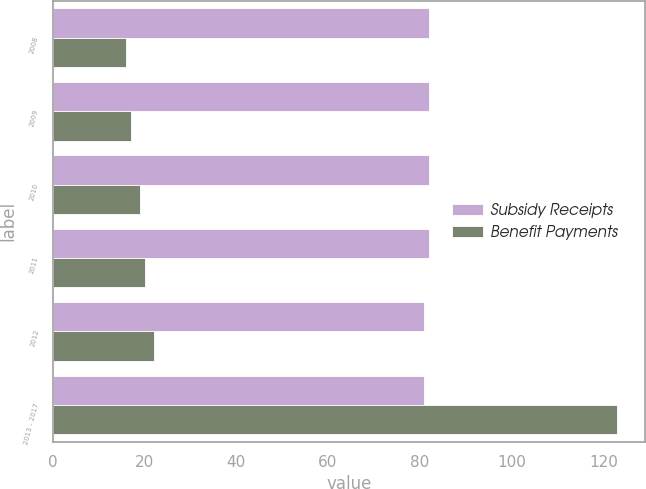<chart> <loc_0><loc_0><loc_500><loc_500><stacked_bar_chart><ecel><fcel>2008<fcel>2009<fcel>2010<fcel>2011<fcel>2012<fcel>2013 - 2017<nl><fcel>Subsidy Receipts<fcel>82<fcel>82<fcel>82<fcel>82<fcel>81<fcel>81<nl><fcel>Benefit Payments<fcel>16<fcel>17<fcel>19<fcel>20<fcel>22<fcel>123<nl></chart> 